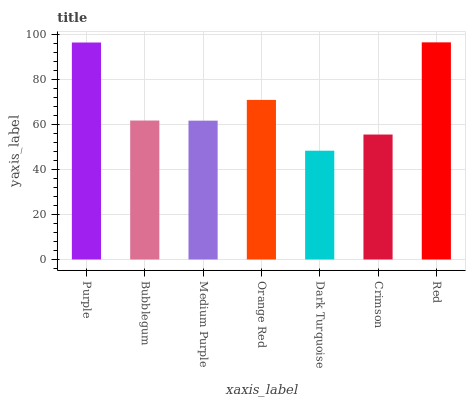Is Dark Turquoise the minimum?
Answer yes or no. Yes. Is Red the maximum?
Answer yes or no. Yes. Is Bubblegum the minimum?
Answer yes or no. No. Is Bubblegum the maximum?
Answer yes or no. No. Is Purple greater than Bubblegum?
Answer yes or no. Yes. Is Bubblegum less than Purple?
Answer yes or no. Yes. Is Bubblegum greater than Purple?
Answer yes or no. No. Is Purple less than Bubblegum?
Answer yes or no. No. Is Bubblegum the high median?
Answer yes or no. Yes. Is Bubblegum the low median?
Answer yes or no. Yes. Is Medium Purple the high median?
Answer yes or no. No. Is Dark Turquoise the low median?
Answer yes or no. No. 